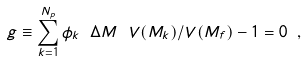<formula> <loc_0><loc_0><loc_500><loc_500>g \equiv \sum _ { k = 1 } ^ { N _ { p } } \phi _ { k } \ \Delta M \ V ( M _ { k } ) / V ( M _ { f } ) - 1 = 0 \ ,</formula> 